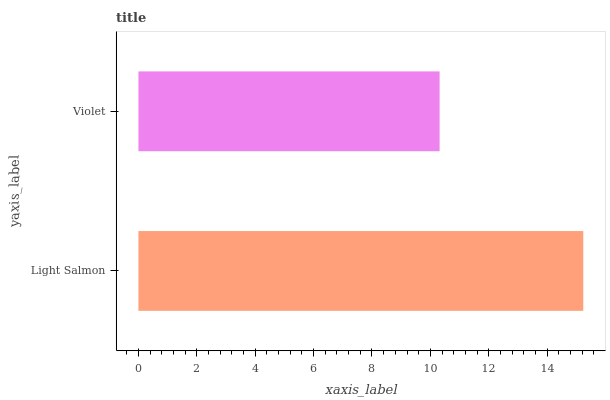Is Violet the minimum?
Answer yes or no. Yes. Is Light Salmon the maximum?
Answer yes or no. Yes. Is Violet the maximum?
Answer yes or no. No. Is Light Salmon greater than Violet?
Answer yes or no. Yes. Is Violet less than Light Salmon?
Answer yes or no. Yes. Is Violet greater than Light Salmon?
Answer yes or no. No. Is Light Salmon less than Violet?
Answer yes or no. No. Is Light Salmon the high median?
Answer yes or no. Yes. Is Violet the low median?
Answer yes or no. Yes. Is Violet the high median?
Answer yes or no. No. Is Light Salmon the low median?
Answer yes or no. No. 